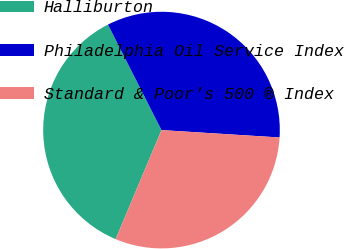Convert chart. <chart><loc_0><loc_0><loc_500><loc_500><pie_chart><fcel>Halliburton<fcel>Philadelphia Oil Service Index<fcel>Standard & Poor's 500 ® Index<nl><fcel>36.19%<fcel>33.47%<fcel>30.34%<nl></chart> 